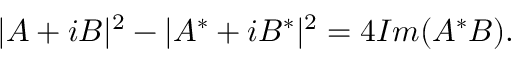Convert formula to latex. <formula><loc_0><loc_0><loc_500><loc_500>| A + i B | ^ { 2 } - | A ^ { * } + i B ^ { * } | ^ { 2 } = 4 I m ( A ^ { * } B ) .</formula> 